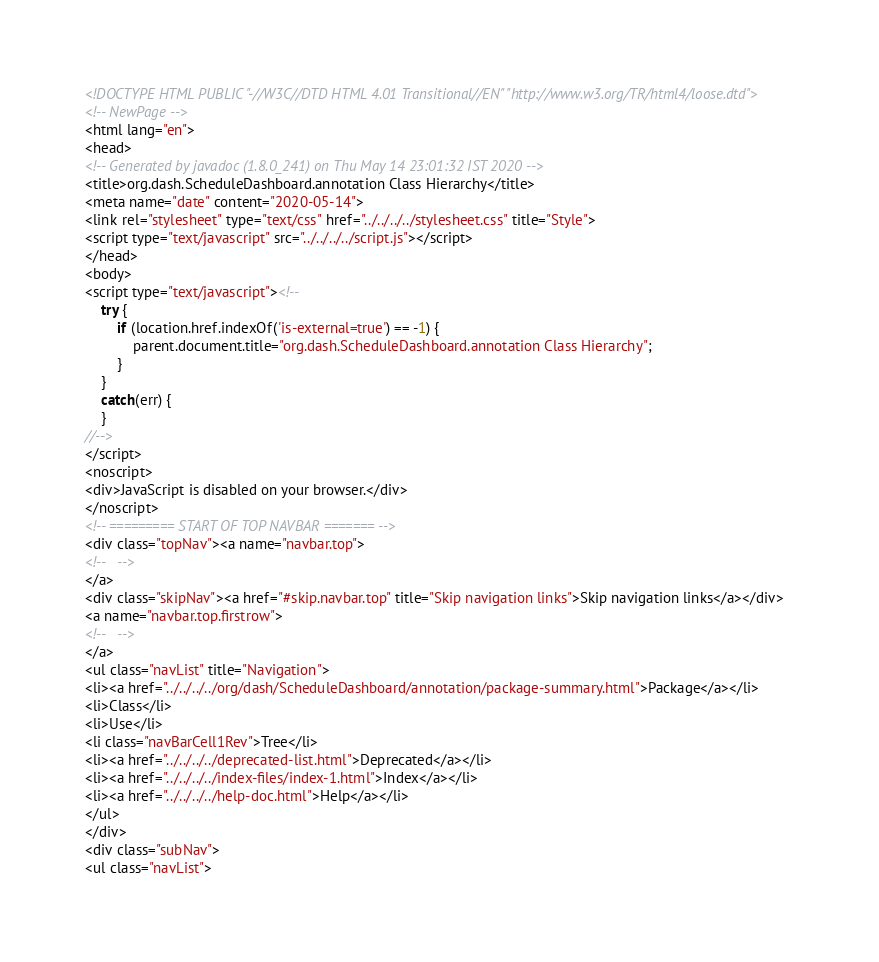Convert code to text. <code><loc_0><loc_0><loc_500><loc_500><_HTML_><!DOCTYPE HTML PUBLIC "-//W3C//DTD HTML 4.01 Transitional//EN" "http://www.w3.org/TR/html4/loose.dtd">
<!-- NewPage -->
<html lang="en">
<head>
<!-- Generated by javadoc (1.8.0_241) on Thu May 14 23:01:32 IST 2020 -->
<title>org.dash.ScheduleDashboard.annotation Class Hierarchy</title>
<meta name="date" content="2020-05-14">
<link rel="stylesheet" type="text/css" href="../../../../stylesheet.css" title="Style">
<script type="text/javascript" src="../../../../script.js"></script>
</head>
<body>
<script type="text/javascript"><!--
    try {
        if (location.href.indexOf('is-external=true') == -1) {
            parent.document.title="org.dash.ScheduleDashboard.annotation Class Hierarchy";
        }
    }
    catch(err) {
    }
//-->
</script>
<noscript>
<div>JavaScript is disabled on your browser.</div>
</noscript>
<!-- ========= START OF TOP NAVBAR ======= -->
<div class="topNav"><a name="navbar.top">
<!--   -->
</a>
<div class="skipNav"><a href="#skip.navbar.top" title="Skip navigation links">Skip navigation links</a></div>
<a name="navbar.top.firstrow">
<!--   -->
</a>
<ul class="navList" title="Navigation">
<li><a href="../../../../org/dash/ScheduleDashboard/annotation/package-summary.html">Package</a></li>
<li>Class</li>
<li>Use</li>
<li class="navBarCell1Rev">Tree</li>
<li><a href="../../../../deprecated-list.html">Deprecated</a></li>
<li><a href="../../../../index-files/index-1.html">Index</a></li>
<li><a href="../../../../help-doc.html">Help</a></li>
</ul>
</div>
<div class="subNav">
<ul class="navList"></code> 